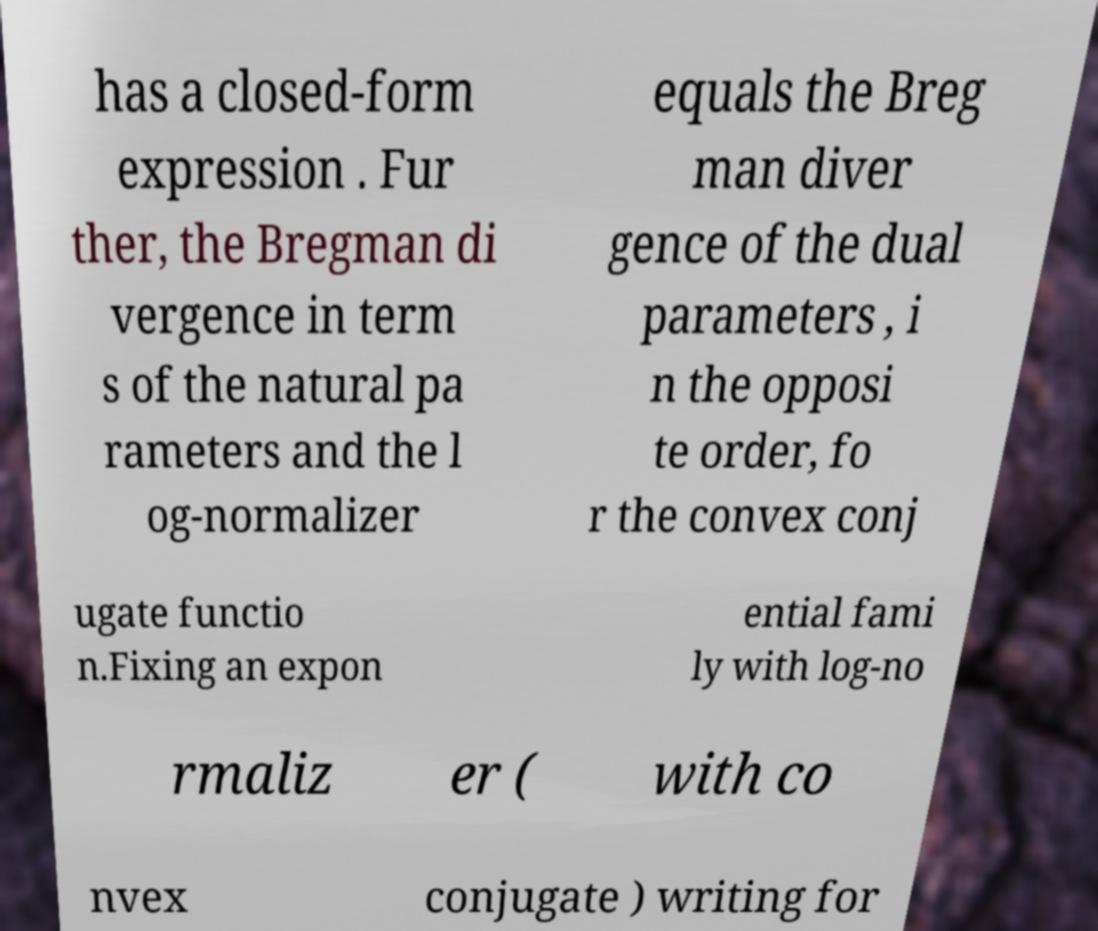For documentation purposes, I need the text within this image transcribed. Could you provide that? has a closed-form expression . Fur ther, the Bregman di vergence in term s of the natural pa rameters and the l og-normalizer equals the Breg man diver gence of the dual parameters , i n the opposi te order, fo r the convex conj ugate functio n.Fixing an expon ential fami ly with log-no rmaliz er ( with co nvex conjugate ) writing for 